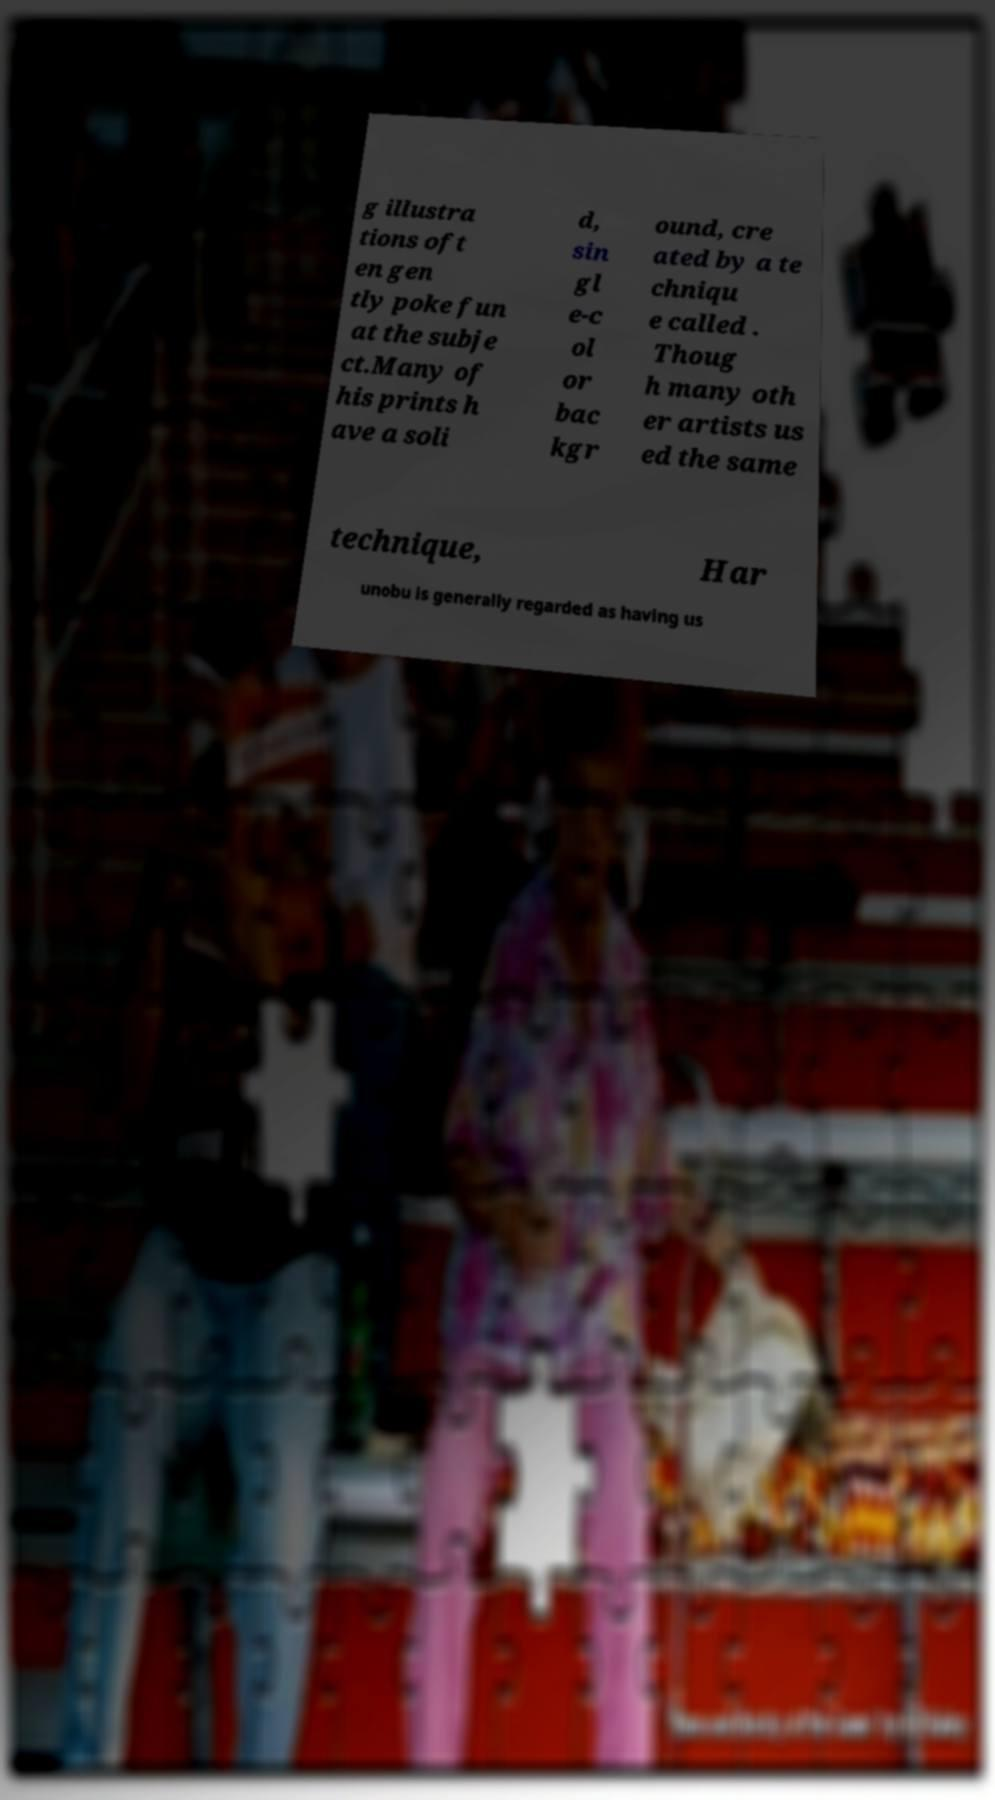Can you read and provide the text displayed in the image?This photo seems to have some interesting text. Can you extract and type it out for me? g illustra tions oft en gen tly poke fun at the subje ct.Many of his prints h ave a soli d, sin gl e-c ol or bac kgr ound, cre ated by a te chniqu e called . Thoug h many oth er artists us ed the same technique, Har unobu is generally regarded as having us 